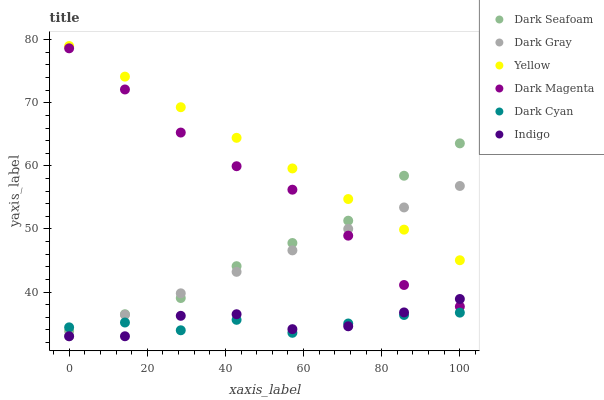Does Dark Cyan have the minimum area under the curve?
Answer yes or no. Yes. Does Yellow have the maximum area under the curve?
Answer yes or no. Yes. Does Dark Magenta have the minimum area under the curve?
Answer yes or no. No. Does Dark Magenta have the maximum area under the curve?
Answer yes or no. No. Is Dark Gray the smoothest?
Answer yes or no. Yes. Is Indigo the roughest?
Answer yes or no. Yes. Is Dark Magenta the smoothest?
Answer yes or no. No. Is Dark Magenta the roughest?
Answer yes or no. No. Does Indigo have the lowest value?
Answer yes or no. Yes. Does Dark Magenta have the lowest value?
Answer yes or no. No. Does Yellow have the highest value?
Answer yes or no. Yes. Does Dark Magenta have the highest value?
Answer yes or no. No. Is Indigo less than Yellow?
Answer yes or no. Yes. Is Yellow greater than Dark Cyan?
Answer yes or no. Yes. Does Dark Magenta intersect Indigo?
Answer yes or no. Yes. Is Dark Magenta less than Indigo?
Answer yes or no. No. Is Dark Magenta greater than Indigo?
Answer yes or no. No. Does Indigo intersect Yellow?
Answer yes or no. No. 